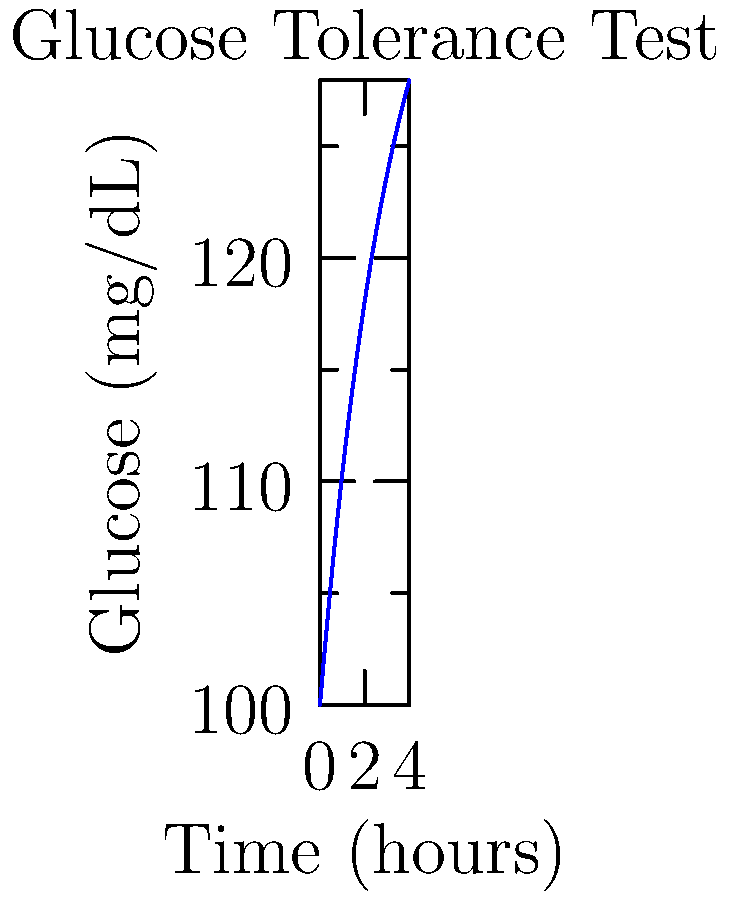A patient undergoes a glucose tolerance test, and their blood glucose levels are measured over time. The graph shows the glucose concentration (mg/dL) as a function of time (hours). Calculate the area under the curve (AUC) for the first 3 hours of the test using the trapezoidal rule with 1-hour intervals. Round your answer to the nearest whole number. To calculate the area under the curve (AUC) using the trapezoidal rule with 1-hour intervals:

1. Identify glucose values at 0, 1, 2, and 3 hours:
   t=0: $f(0) = 140 - 40e^{-0.3 \cdot 0} = 100$ mg/dL
   t=1: $f(1) = 140 - 40e^{-0.3 \cdot 1} \approx 128$ mg/dL
   t=2: $f(2) = 140 - 40e^{-0.3 \cdot 2} \approx 136$ mg/dL
   t=3: $f(3) = 140 - 40e^{-0.3 \cdot 3} \approx 138$ mg/dL

2. Apply the trapezoidal rule:
   AUC = $\frac{1}{2}(f(0) + f(1)) + \frac{1}{2}(f(1) + f(2)) + \frac{1}{2}(f(2) + f(3))$

3. Substitute values:
   AUC = $\frac{1}{2}(100 + 128) + \frac{1}{2}(128 + 136) + \frac{1}{2}(136 + 138)$
       = $114 + 132 + 137$
       = $383$ mg·h/dL

4. Round to the nearest whole number: 383 mg·h/dL
Answer: 383 mg·h/dL 